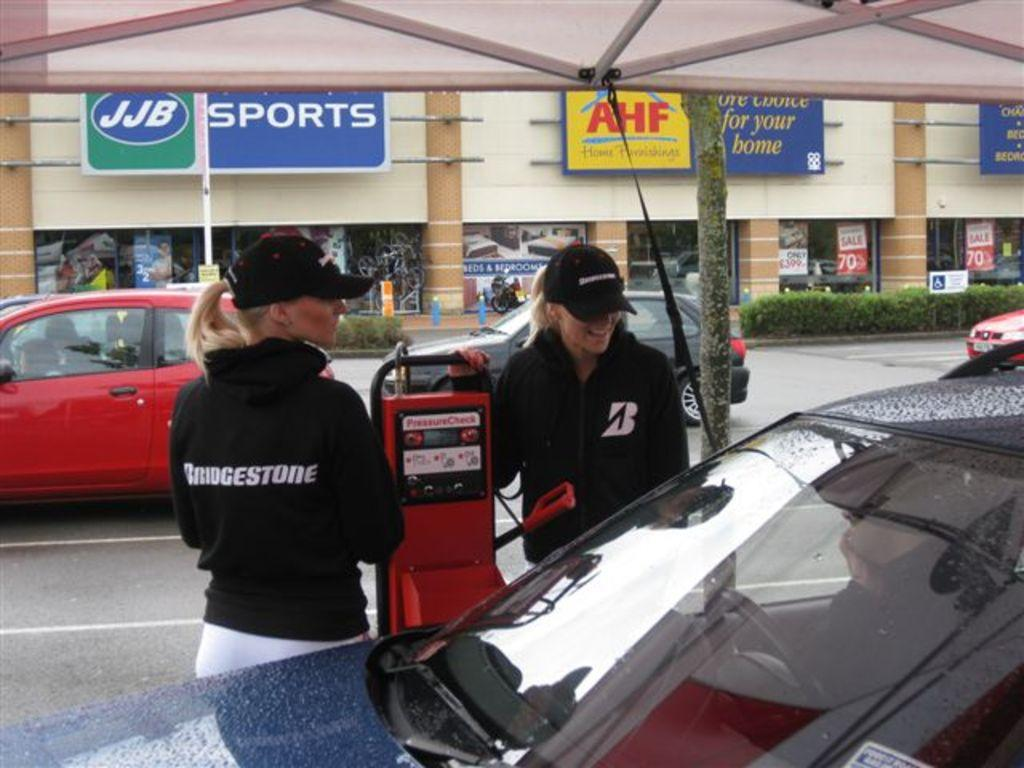How many women are present in the image? There are two women standing on the road in the image. What else can be seen on the road besides the women? There are cars on the road. What type of structure is visible in the image? There is a building visible in the image. What type of fruit is the baby holding in the image? There is no baby or fruit present in the image. 